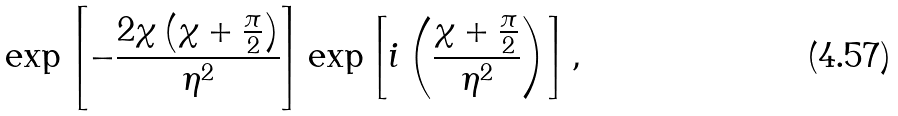Convert formula to latex. <formula><loc_0><loc_0><loc_500><loc_500>\exp \left [ - \frac { 2 \chi \left ( \chi + \frac { \pi } { 2 } \right ) } { \eta ^ { 2 } } \right ] \exp \left [ i \left ( \frac { \chi + \frac { \pi } { 2 } } { \eta ^ { 2 } } \right ) \right ] ,</formula> 